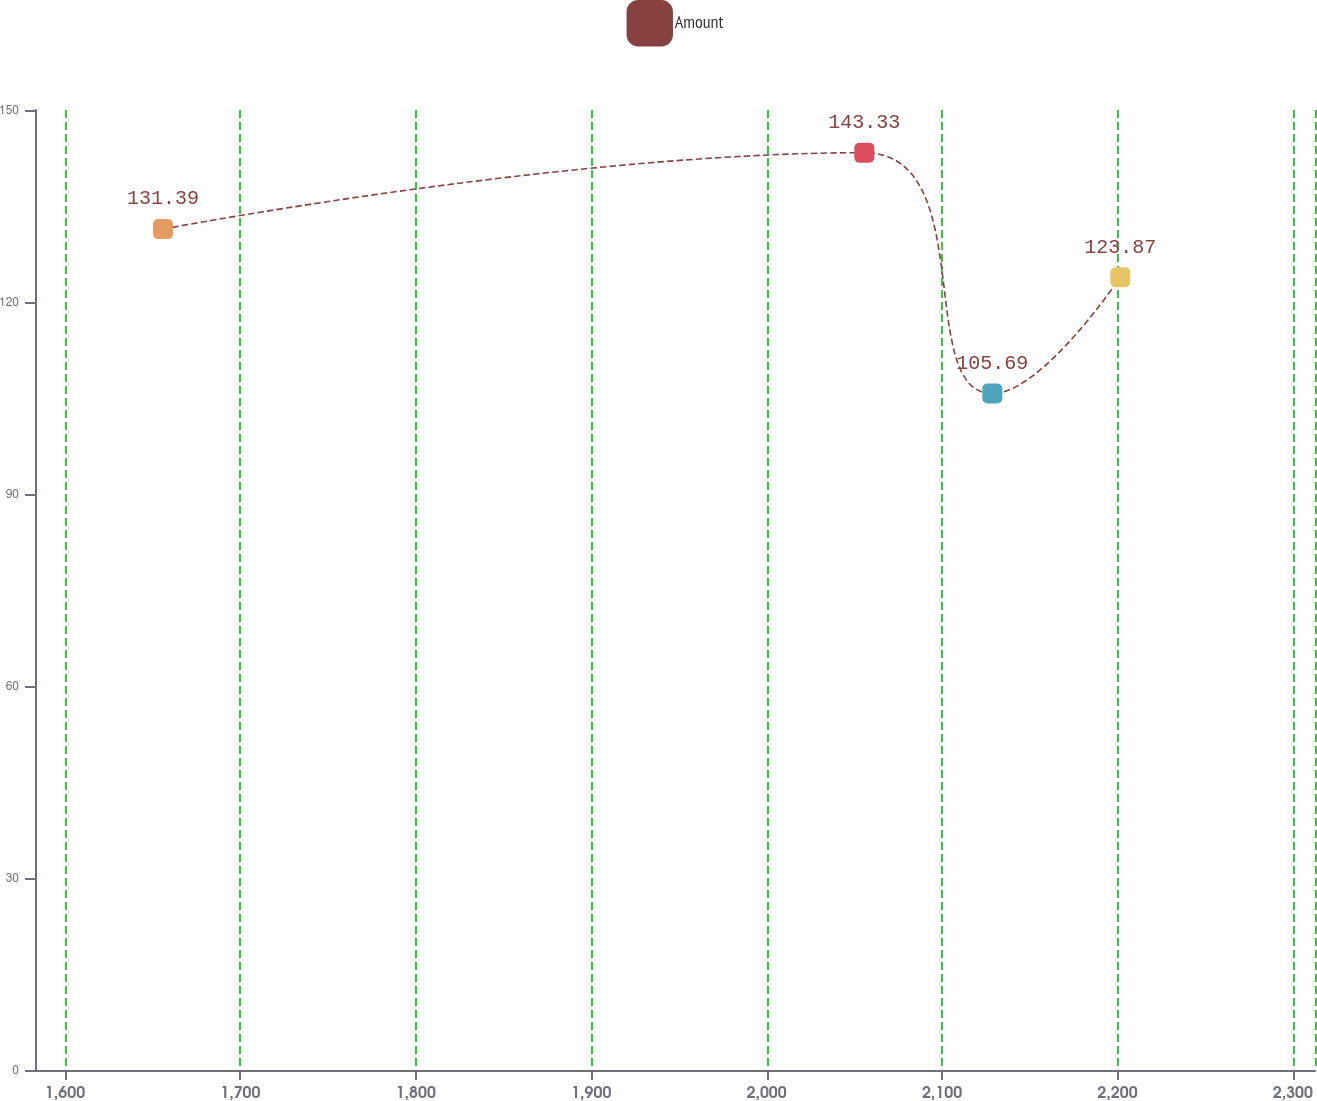Convert chart to OTSL. <chart><loc_0><loc_0><loc_500><loc_500><line_chart><ecel><fcel>Amount<nl><fcel>1655.89<fcel>131.39<nl><fcel>2055.69<fcel>143.33<nl><fcel>2128.66<fcel>105.69<nl><fcel>2201.63<fcel>123.87<nl><fcel>2385.58<fcel>127.63<nl></chart> 